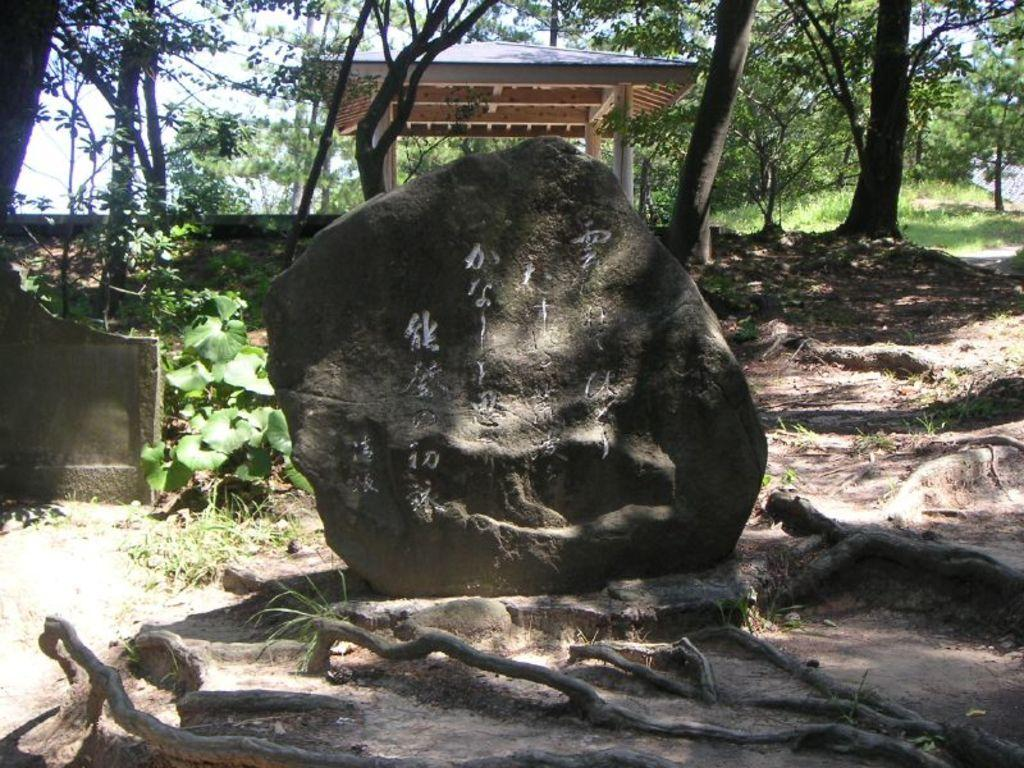What is the main object in the image? There is a rock in the image. What is written or depicted on the rock? There is text on the rock. What can be seen at the bottom of the image? There are roots of a tree at the bottom of the image. What structures can be seen in the background of the image? There is a shed and trees in the background of the image. What type of vegetation is visible in the background of the image? There are plants in the background of the image. Who is the creator of the rock in the image? The image does not provide information about the creator of the rock. The rock is a natural object, and its formation is a result of geological processes. 